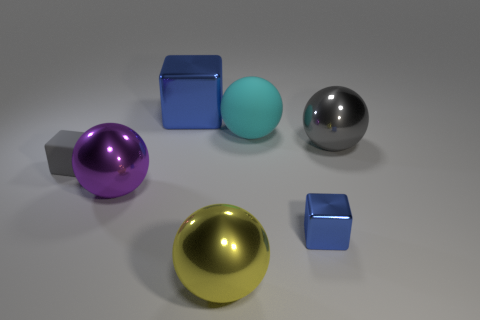Does the tiny shiny object have the same color as the large metallic cube?
Your answer should be very brief. Yes. What is the shape of the rubber object that is right of the metal sphere that is to the left of the yellow metal thing?
Provide a short and direct response. Sphere. There is a purple object that is the same material as the big yellow sphere; what shape is it?
Provide a succinct answer. Sphere. What is the size of the blue metallic thing to the left of the ball that is behind the gray ball?
Your answer should be very brief. Large. What shape is the gray matte object?
Your answer should be very brief. Cube. How many big things are either blue objects or cyan objects?
Keep it short and to the point. 2. There is another metallic thing that is the same shape as the small shiny object; what size is it?
Provide a short and direct response. Large. How many shiny objects are left of the large gray thing and to the right of the cyan rubber thing?
Provide a short and direct response. 1. There is a cyan object; is it the same shape as the gray thing on the right side of the yellow metallic ball?
Ensure brevity in your answer.  Yes. Are there more large gray things left of the tiny gray rubber cube than blue matte balls?
Your answer should be compact. No. 